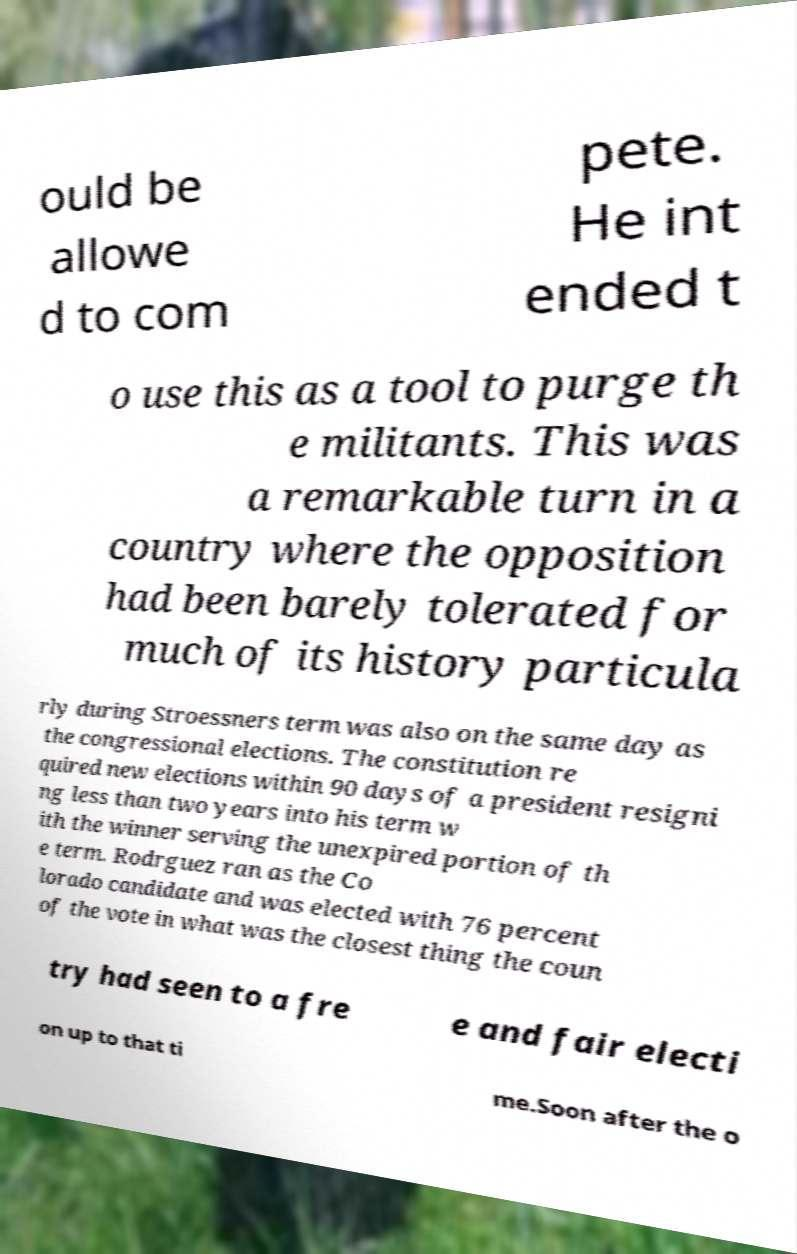There's text embedded in this image that I need extracted. Can you transcribe it verbatim? ould be allowe d to com pete. He int ended t o use this as a tool to purge th e militants. This was a remarkable turn in a country where the opposition had been barely tolerated for much of its history particula rly during Stroessners term was also on the same day as the congressional elections. The constitution re quired new elections within 90 days of a president resigni ng less than two years into his term w ith the winner serving the unexpired portion of th e term. Rodrguez ran as the Co lorado candidate and was elected with 76 percent of the vote in what was the closest thing the coun try had seen to a fre e and fair electi on up to that ti me.Soon after the o 